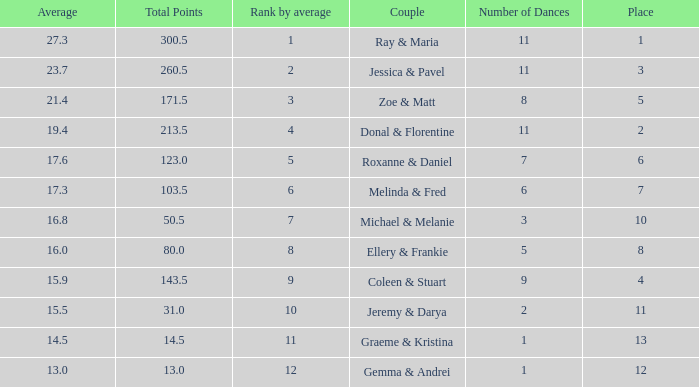What place would you be in if your rank by average is less than 2.0? 1.0. 